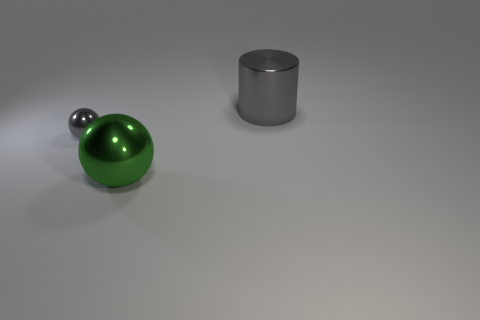What is the material of the other object that is the same color as the small metallic object?
Your answer should be compact. Metal. Is the number of large cyan objects greater than the number of small gray things?
Offer a very short reply. No. What number of other things are there of the same material as the big sphere
Provide a short and direct response. 2. What shape is the green metallic object in front of the sphere that is on the left side of the large metallic object that is to the left of the gray cylinder?
Offer a very short reply. Sphere. Are there fewer gray metallic spheres right of the large ball than small gray balls that are behind the small sphere?
Keep it short and to the point. No. Are there any large metal things of the same color as the tiny ball?
Offer a very short reply. Yes. Is the material of the small gray thing the same as the big thing that is left of the gray metallic cylinder?
Give a very brief answer. Yes. There is a metal sphere in front of the tiny gray thing; are there any green spheres behind it?
Provide a short and direct response. No. What is the color of the object that is both to the right of the small gray metallic ball and in front of the large gray metallic cylinder?
Make the answer very short. Green. The green thing is what size?
Provide a succinct answer. Large. 